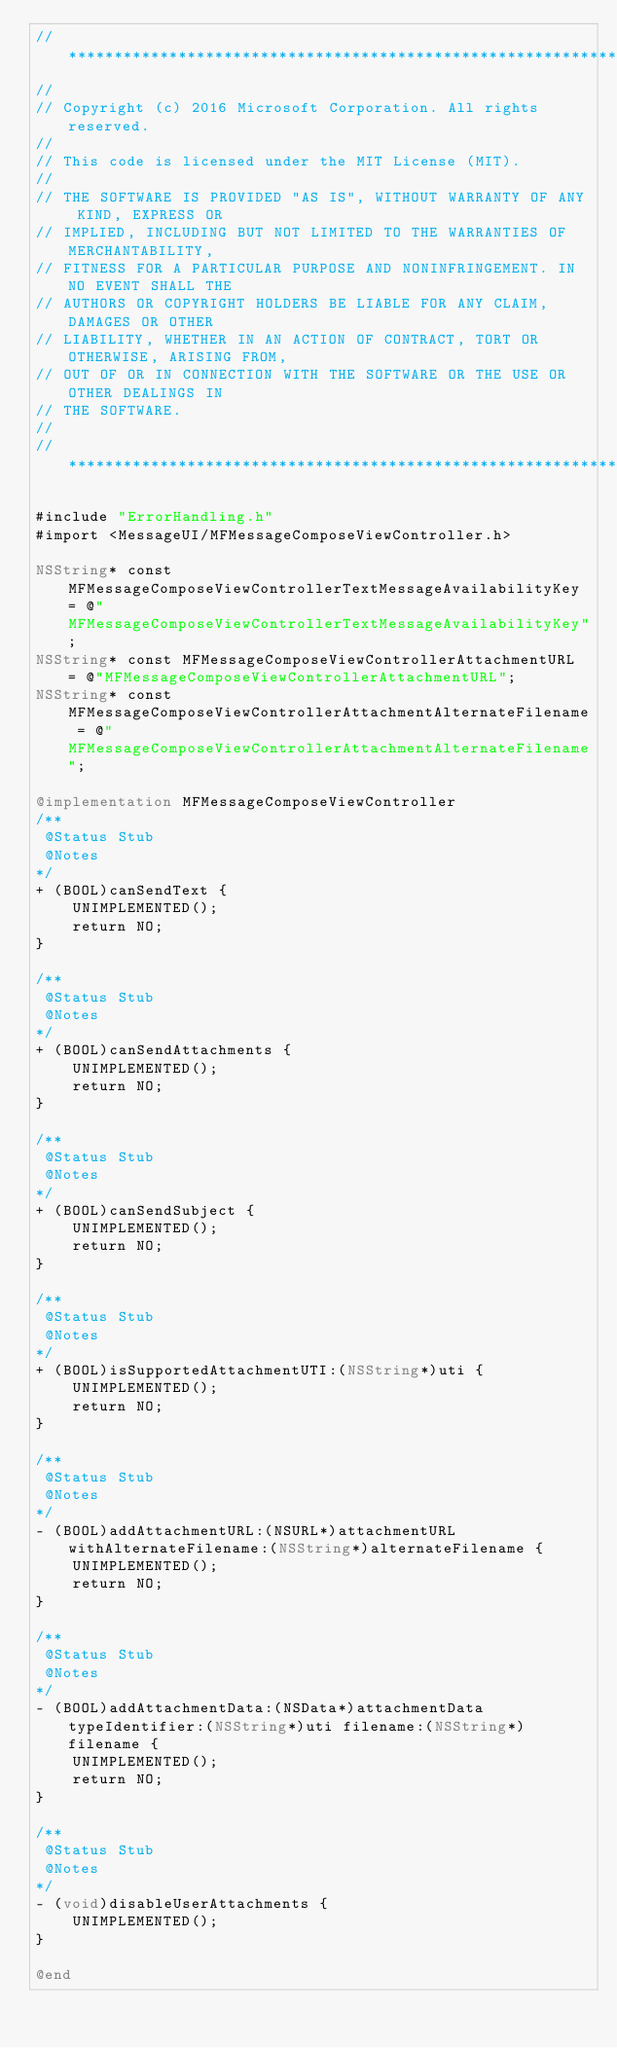Convert code to text. <code><loc_0><loc_0><loc_500><loc_500><_ObjectiveC_>//******************************************************************************
//
// Copyright (c) 2016 Microsoft Corporation. All rights reserved.
//
// This code is licensed under the MIT License (MIT).
//
// THE SOFTWARE IS PROVIDED "AS IS", WITHOUT WARRANTY OF ANY KIND, EXPRESS OR
// IMPLIED, INCLUDING BUT NOT LIMITED TO THE WARRANTIES OF MERCHANTABILITY,
// FITNESS FOR A PARTICULAR PURPOSE AND NONINFRINGEMENT. IN NO EVENT SHALL THE
// AUTHORS OR COPYRIGHT HOLDERS BE LIABLE FOR ANY CLAIM, DAMAGES OR OTHER
// LIABILITY, WHETHER IN AN ACTION OF CONTRACT, TORT OR OTHERWISE, ARISING FROM,
// OUT OF OR IN CONNECTION WITH THE SOFTWARE OR THE USE OR OTHER DEALINGS IN
// THE SOFTWARE.
//
//******************************************************************************

#include "ErrorHandling.h"
#import <MessageUI/MFMessageComposeViewController.h>

NSString* const MFMessageComposeViewControllerTextMessageAvailabilityKey = @"MFMessageComposeViewControllerTextMessageAvailabilityKey";
NSString* const MFMessageComposeViewControllerAttachmentURL = @"MFMessageComposeViewControllerAttachmentURL";
NSString* const MFMessageComposeViewControllerAttachmentAlternateFilename = @"MFMessageComposeViewControllerAttachmentAlternateFilename";

@implementation MFMessageComposeViewController
/**
 @Status Stub
 @Notes
*/
+ (BOOL)canSendText {
    UNIMPLEMENTED();
    return NO;
}

/**
 @Status Stub
 @Notes
*/
+ (BOOL)canSendAttachments {
    UNIMPLEMENTED();
    return NO;
}

/**
 @Status Stub
 @Notes
*/
+ (BOOL)canSendSubject {
    UNIMPLEMENTED();
    return NO;
}

/**
 @Status Stub
 @Notes
*/
+ (BOOL)isSupportedAttachmentUTI:(NSString*)uti {
    UNIMPLEMENTED();
    return NO;
}

/**
 @Status Stub
 @Notes
*/
- (BOOL)addAttachmentURL:(NSURL*)attachmentURL withAlternateFilename:(NSString*)alternateFilename {
    UNIMPLEMENTED();
    return NO;
}

/**
 @Status Stub
 @Notes
*/
- (BOOL)addAttachmentData:(NSData*)attachmentData typeIdentifier:(NSString*)uti filename:(NSString*)filename {
    UNIMPLEMENTED();
    return NO;
}

/**
 @Status Stub
 @Notes
*/
- (void)disableUserAttachments {
    UNIMPLEMENTED();
}

@end
</code> 